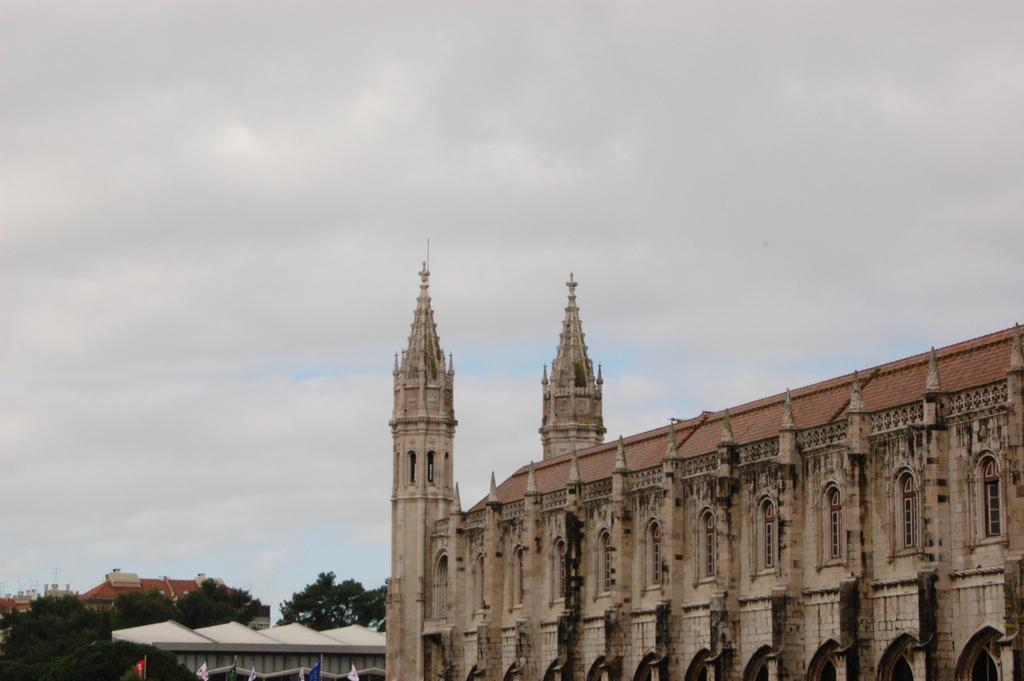What structure is located on the right side of the image? There is a building on the right side of the image. What type of vegetation is on the left side of the image? There are trees on the left side of the image. What is visible at the top of the image? The sky is cloudy and visible at the top of the image. Where is the shop located in the image? There is no shop mentioned or visible in the image. What type of rake is being used to clear the leaves in the image? There is no rake present in the image; it only features a building, trees, and a cloudy sky. 